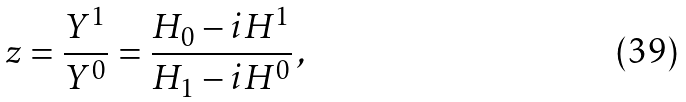<formula> <loc_0><loc_0><loc_500><loc_500>z = \frac { Y ^ { 1 } } { Y ^ { 0 } } = \frac { H _ { 0 } - i H ^ { 1 } } { H _ { 1 } - i H ^ { 0 } } \, ,</formula> 